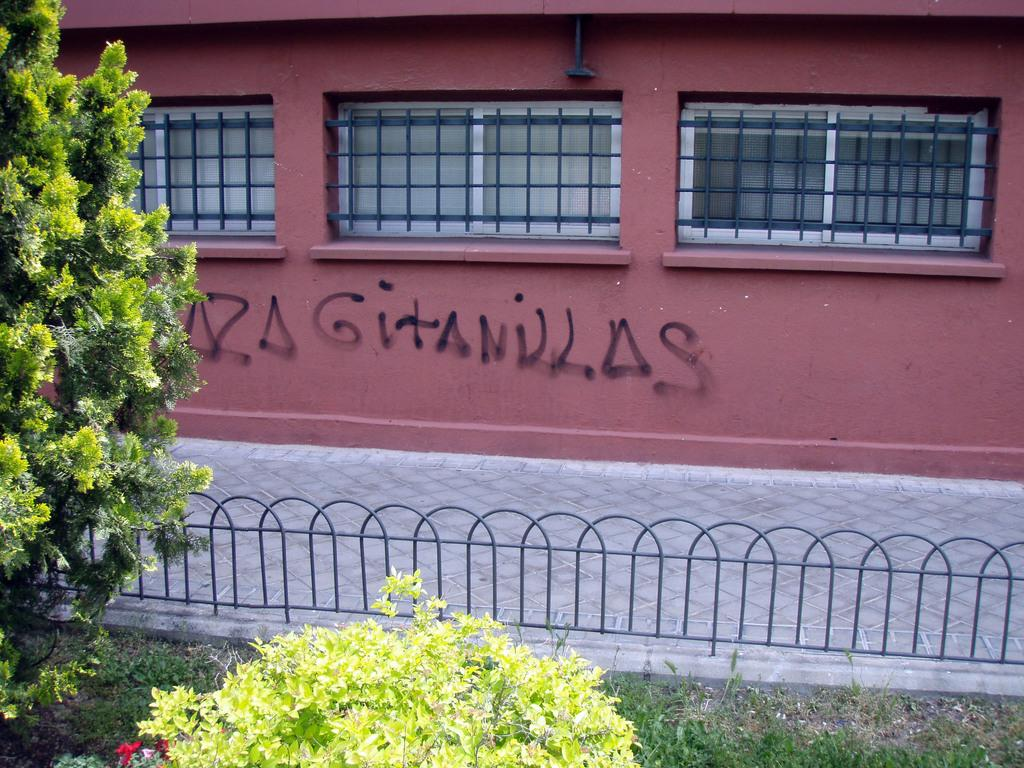What type of vegetation can be seen in the image? There is grass, a plant, and a tree in the image. What is the purpose of the fence in the image? The fence in the image serves as a boundary or barrier. What type of structure is present in the image? There is a building in the image. Is there any text or writing visible in the image? Yes, there is writing on the building in the image. What type of match can be seen in the image? There is no match present in the image. Is there a picture of a camera in the image? There is no camera or picture of a camera present in the image. 